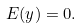<formula> <loc_0><loc_0><loc_500><loc_500>E ( y ) = 0 .</formula> 